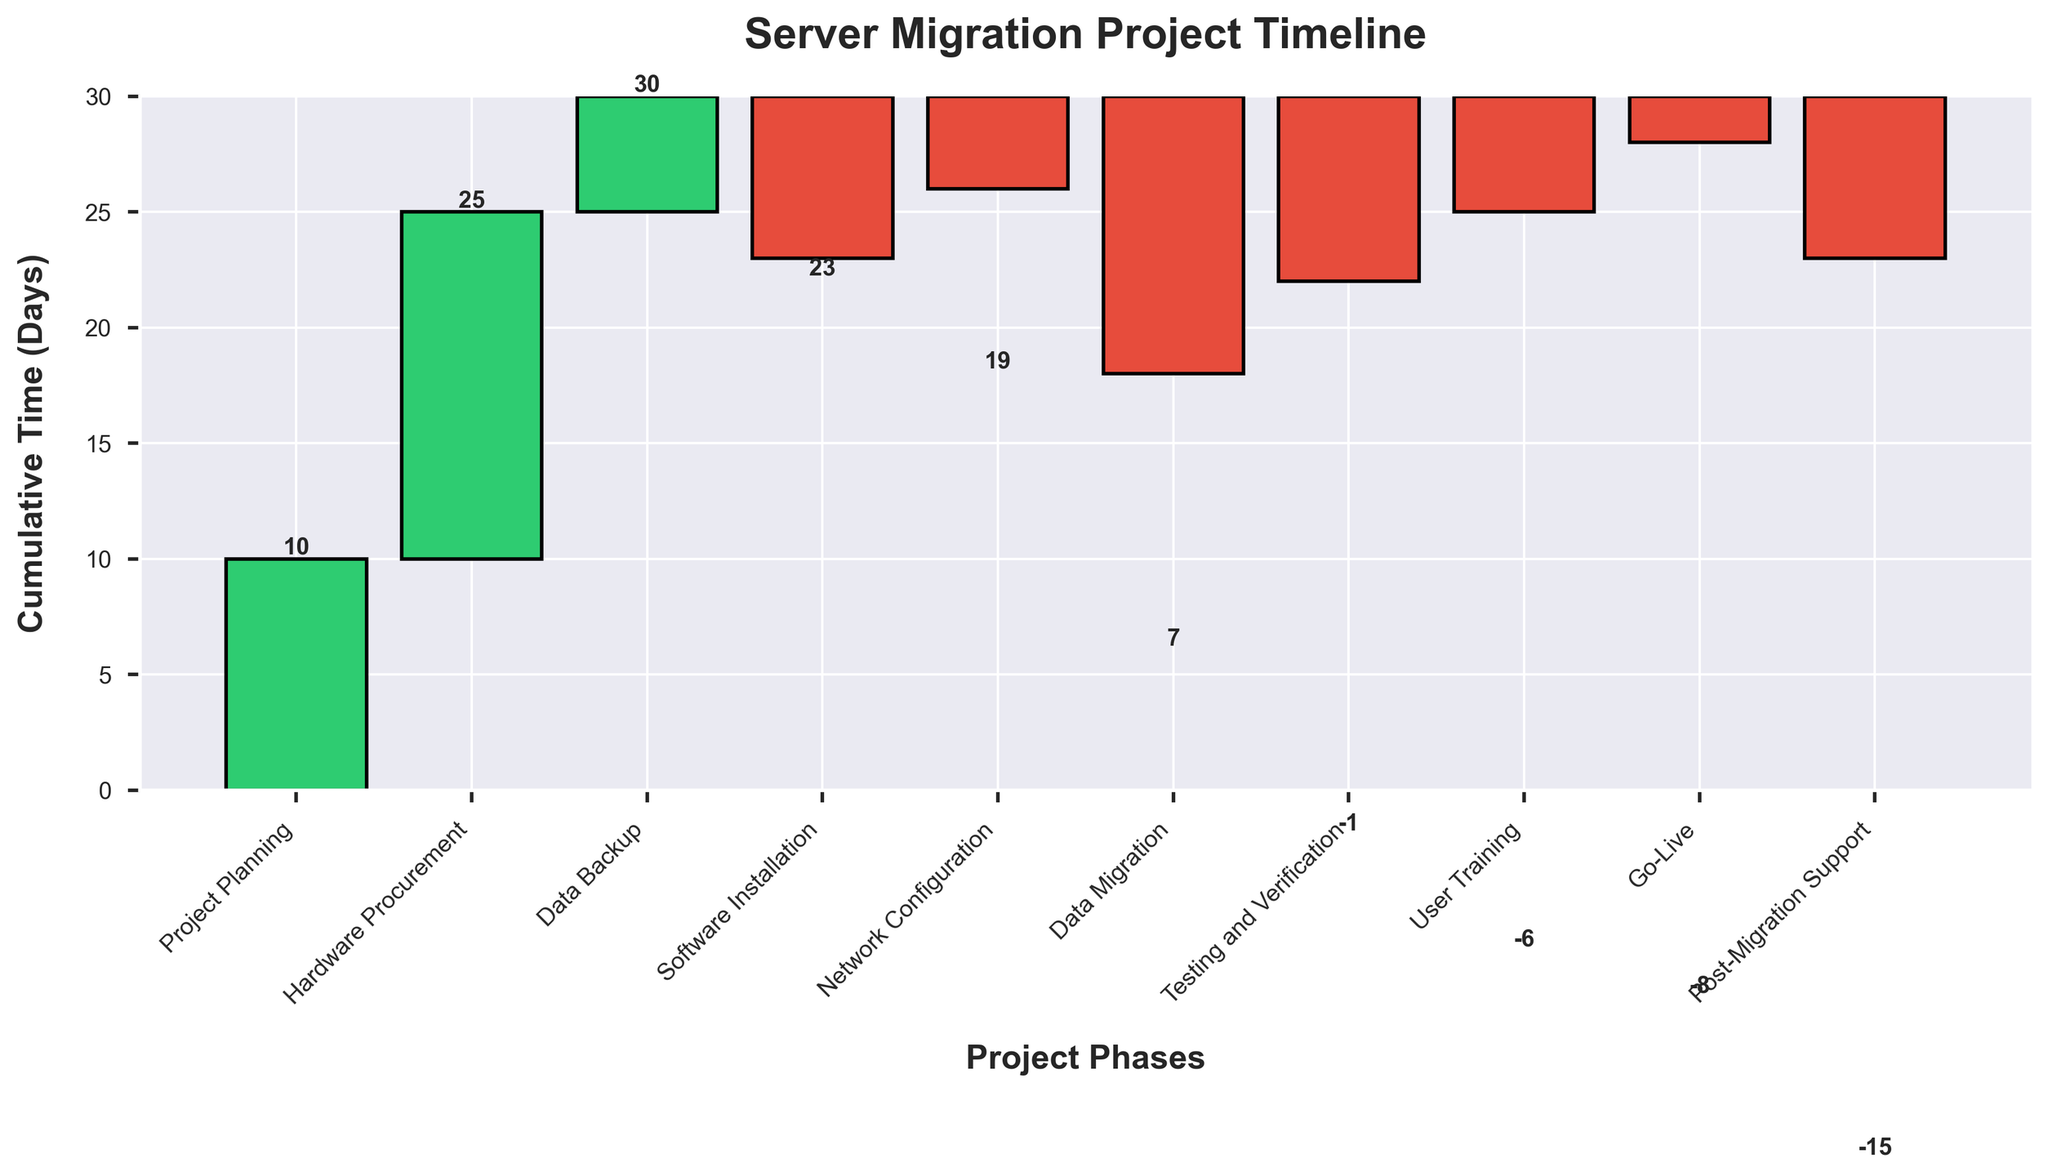What is the title of the chart? The title is typically found at the top of the chart. In this case, it is displayed prominently and is written in a bold font.
Answer: Server Migration Project Timeline Which phase took the longest time? To find the longest time spent in any phase, look at the highest bar extending from the baseline.
Answer: Hardware Procurement How much time was spent overall before reaching the Go-Live phase? Sum up all the cumulative times before reaching the Go-Live phase. This includes Project Planning, Hardware Procurement, Data Backup, Software Installation, Network Configuration, Data Migration, Testing and Verification, User Training, and Go-Live.
Answer: 8 days What is the net time saved due to negative values in the chart? Add all the negative values (Software Installation, Network Configuration, Data Migration, Testing and Verification, User Training, Go-Live, Post-Migration Support). These values represent saved time or time reductions.
Answer: -45 days How does the cumulative time change after the Data Migration phase? Observe the cumulative time at Data Migration and compare it with the subsequent phases. Specifically, look at the values at Data Migration and Testing and Verification.
Answer: Reduces by 4 days Which phases have negative time values, and what does this signify? Identify phases with bars below the baseline. Negative values often indicate tasks that reduced overall time or were completed quicker than anticipated.
Answer: Software Installation, Network Configuration, Data Migration, Testing and Verification, User Training, Go-Live, Post-Migration Support What is the cumulative time at the end of User Training? Track the cumulative values displayed on top of the bars up to the end of User Training.
Answer: 6 days How much additional time was required for Post-Migration Support compared to Go-Live? Look at the absolute values of Go-Live and Post-Migration Support, then calculate the difference.
Answer: 5 days Compare the total time impact of Software Installation and Network Configuration. Which had a greater reduction? Examine the negative values for both phases and compare their magnitudes.
Answer: Software Installation How much time was spent on Testing and Verification? Check the length and value of the Testing and Verification bar.
Answer: -8 days 